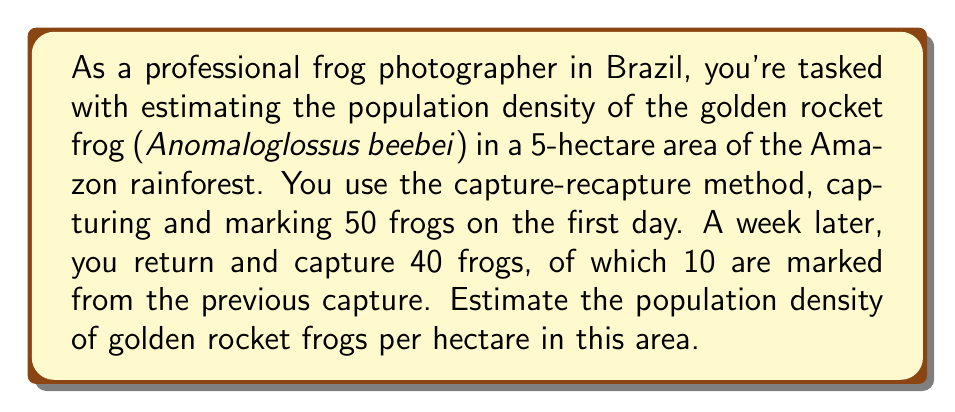Solve this math problem. To solve this problem, we'll use the Lincoln-Petersen method for population estimation and then calculate the density per hectare. Let's break it down step-by-step:

1) The Lincoln-Petersen formula for population estimation is:

   $$N = \frac{MC}{R}$$

   Where:
   $N$ = estimated population size
   $M$ = number of individuals marked on first visit
   $C$ = number of individuals captured on second visit
   $R$ = number of marked individuals recaptured on second visit

2) From the given information:
   $M = 50$ (frogs marked on first day)
   $C = 40$ (frogs captured on second visit)
   $R = 10$ (marked frogs recaptured on second visit)

3) Let's substitute these values into the formula:

   $$N = \frac{50 \times 40}{10} = \frac{2000}{10} = 200$$

4) So, the estimated population in the 5-hectare area is 200 frogs.

5) To calculate the density per hectare, we divide the total population by the area:

   $$\text{Density} = \frac{\text{Population}}{\text{Area}} = \frac{200 \text{ frogs}}{5 \text{ hectares}} = 40 \text{ frogs/hectare}$$

Therefore, the estimated population density is 40 golden rocket frogs per hectare.
Answer: 40 frogs per hectare 